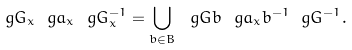Convert formula to latex. <formula><loc_0><loc_0><loc_500><loc_500>\ g G _ { x } \ g a _ { x } \ g G _ { x } ^ { - 1 } = \bigcup _ { b \in B } \ g G b \ g a _ { x } b ^ { - 1 } \ g G ^ { - 1 } .</formula> 